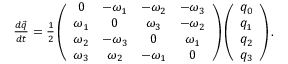Convert formula to latex. <formula><loc_0><loc_0><loc_500><loc_500>\begin{array} { r } { \frac { d \ V e c { q } } { d t } = \frac { 1 } { 2 } \left ( \begin{array} { c c c c } { 0 } & { - \omega _ { 1 } } & { - \omega _ { 2 } } & { - \omega _ { 3 } } \\ { \omega _ { 1 } } & { 0 } & { \omega _ { 3 } } & { - \omega _ { 2 } } \\ { \omega _ { 2 } } & { - \omega _ { 3 } } & { 0 } & { \omega _ { 1 } } \\ { \omega _ { 3 } } & { \omega _ { 2 } } & { - \omega _ { 1 } } & { 0 } \end{array} \right ) \left ( \begin{array} { c c c c } { q _ { 0 } } \\ { q _ { 1 } } \\ { q _ { 2 } } \\ { q _ { 3 } } \end{array} \right ) . } \end{array}</formula> 